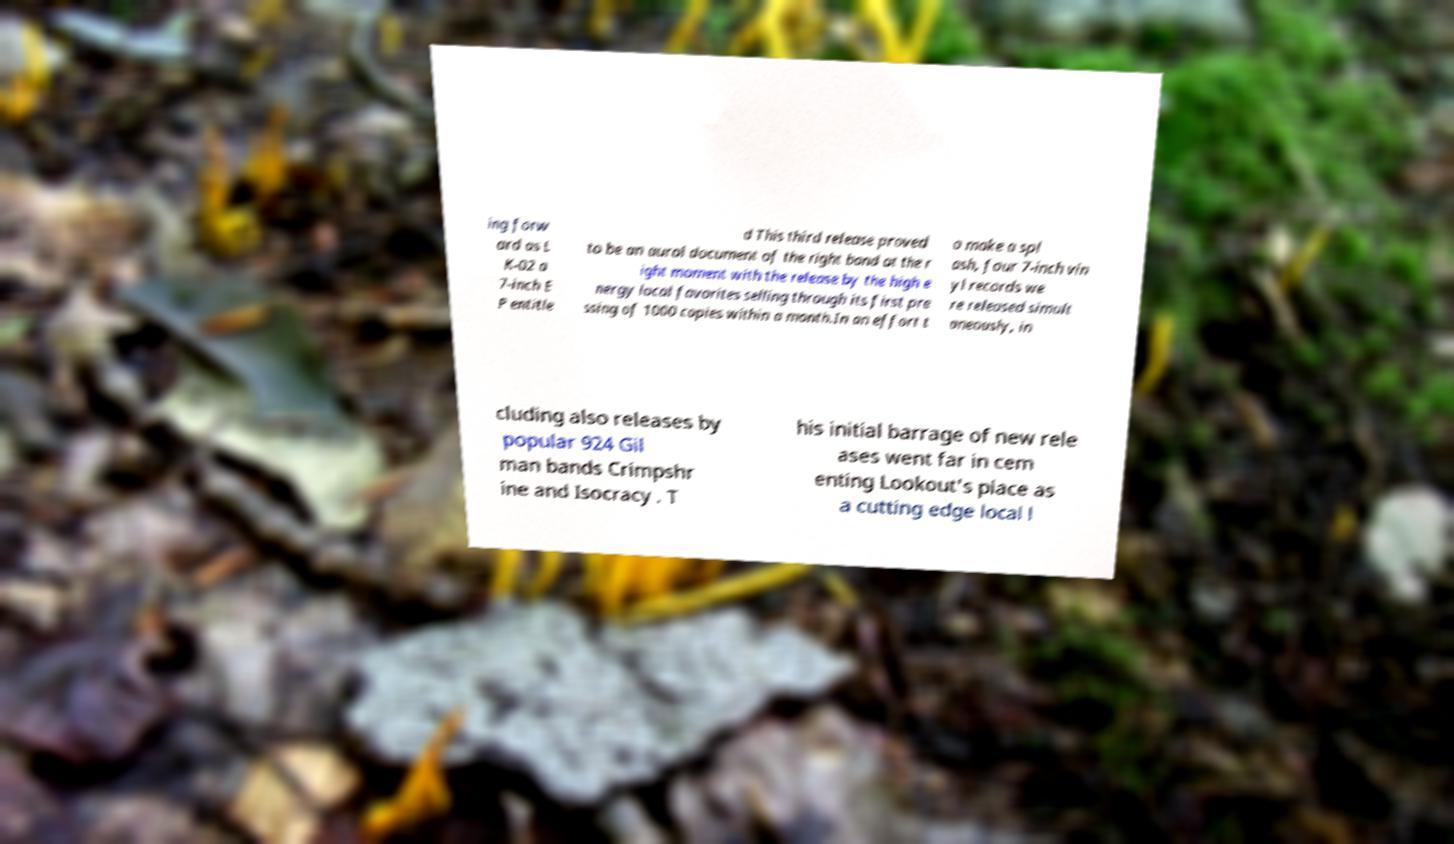What messages or text are displayed in this image? I need them in a readable, typed format. ing forw ard as L K-02 a 7-inch E P entitle d This third release proved to be an aural document of the right band at the r ight moment with the release by the high e nergy local favorites selling through its first pre ssing of 1000 copies within a month.In an effort t o make a spl ash, four 7-inch vin yl records we re released simult aneously, in cluding also releases by popular 924 Gil man bands Crimpshr ine and Isocracy . T his initial barrage of new rele ases went far in cem enting Lookout's place as a cutting edge local l 